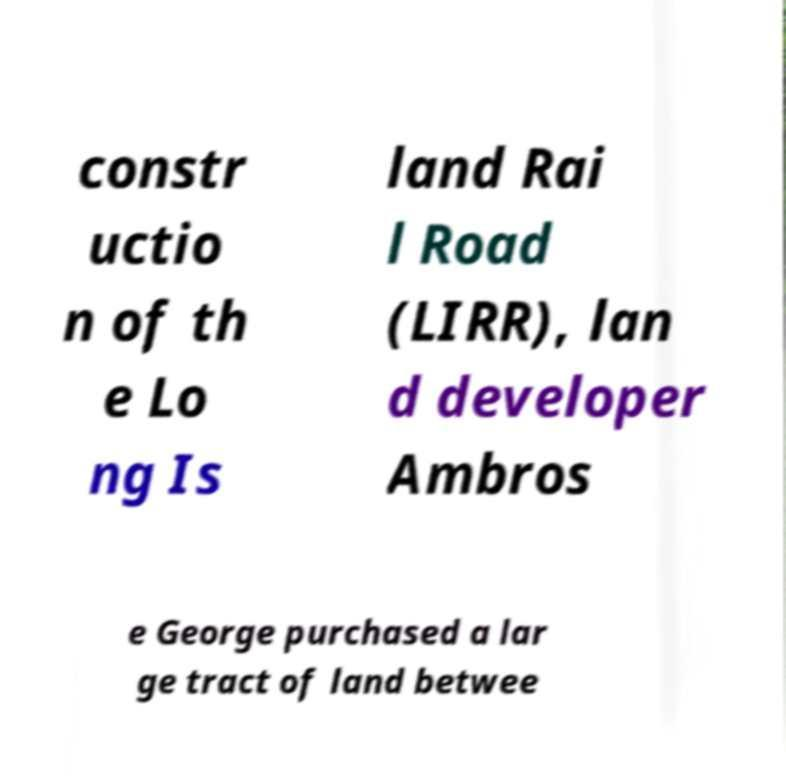I need the written content from this picture converted into text. Can you do that? constr uctio n of th e Lo ng Is land Rai l Road (LIRR), lan d developer Ambros e George purchased a lar ge tract of land betwee 